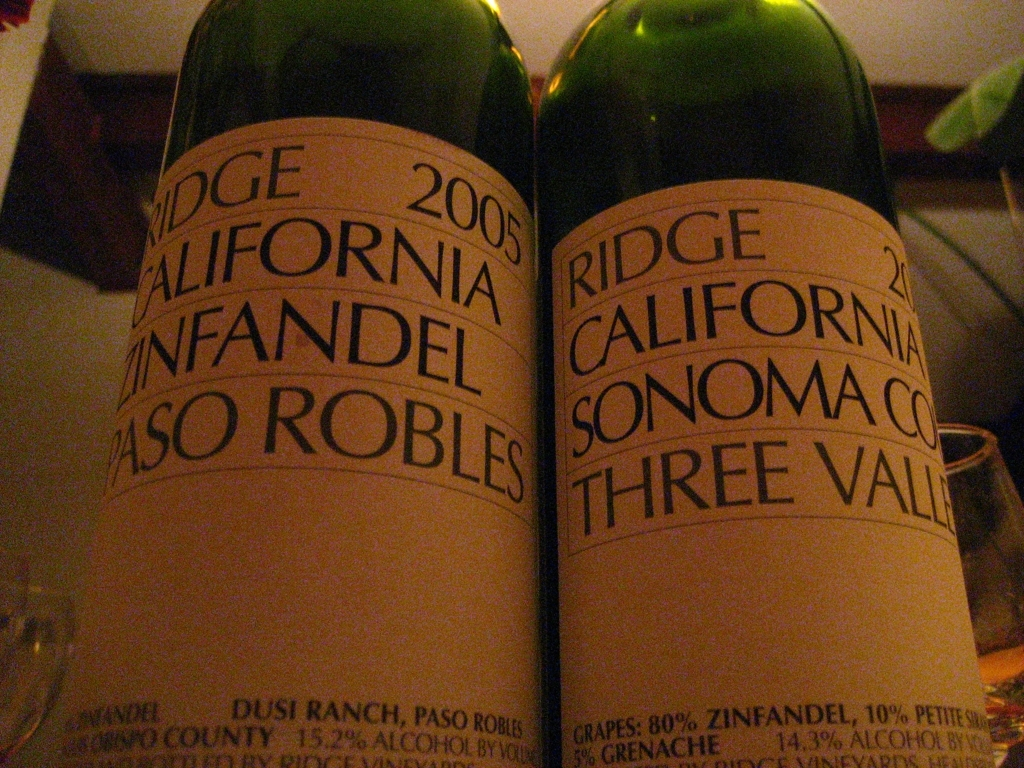Break down the quality aspects of the image and judge it from your analysis. The image showcases two wine bottles, capturing their labels which display key information with good clarity, especially the text indicating the wine type and origin. However, the image suffers from a low light condition, which has introduced graininess and reduced color vibrancy. Improving the lighting conditions could enhance the visibility of the texture of the paper labels and the true colors of the design, making the overall aesthetic more appealing. Despite these issues, the labels are legible, which is crucial for consumer understanding and branding. 